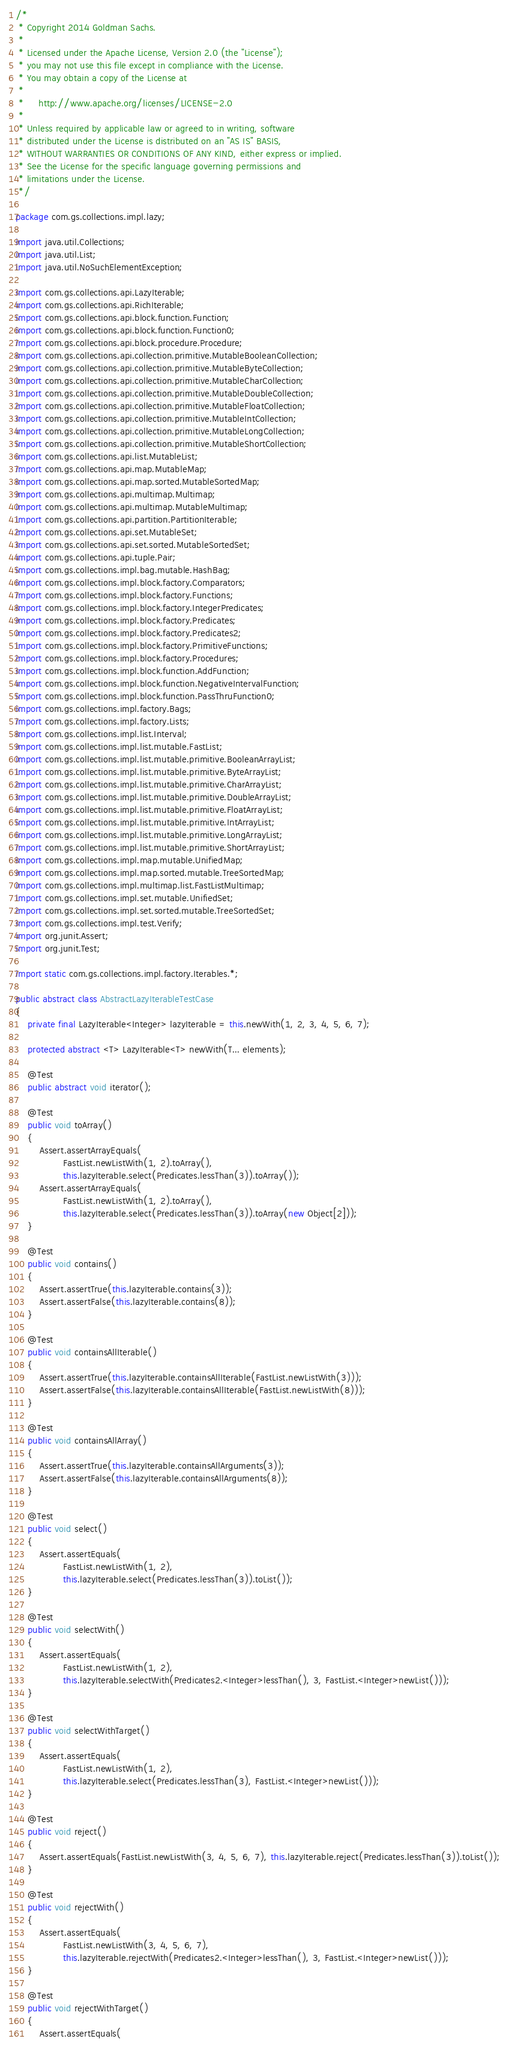<code> <loc_0><loc_0><loc_500><loc_500><_Java_>/*
 * Copyright 2014 Goldman Sachs.
 *
 * Licensed under the Apache License, Version 2.0 (the "License");
 * you may not use this file except in compliance with the License.
 * You may obtain a copy of the License at
 *
 *     http://www.apache.org/licenses/LICENSE-2.0
 *
 * Unless required by applicable law or agreed to in writing, software
 * distributed under the License is distributed on an "AS IS" BASIS,
 * WITHOUT WARRANTIES OR CONDITIONS OF ANY KIND, either express or implied.
 * See the License for the specific language governing permissions and
 * limitations under the License.
 */

package com.gs.collections.impl.lazy;

import java.util.Collections;
import java.util.List;
import java.util.NoSuchElementException;

import com.gs.collections.api.LazyIterable;
import com.gs.collections.api.RichIterable;
import com.gs.collections.api.block.function.Function;
import com.gs.collections.api.block.function.Function0;
import com.gs.collections.api.block.procedure.Procedure;
import com.gs.collections.api.collection.primitive.MutableBooleanCollection;
import com.gs.collections.api.collection.primitive.MutableByteCollection;
import com.gs.collections.api.collection.primitive.MutableCharCollection;
import com.gs.collections.api.collection.primitive.MutableDoubleCollection;
import com.gs.collections.api.collection.primitive.MutableFloatCollection;
import com.gs.collections.api.collection.primitive.MutableIntCollection;
import com.gs.collections.api.collection.primitive.MutableLongCollection;
import com.gs.collections.api.collection.primitive.MutableShortCollection;
import com.gs.collections.api.list.MutableList;
import com.gs.collections.api.map.MutableMap;
import com.gs.collections.api.map.sorted.MutableSortedMap;
import com.gs.collections.api.multimap.Multimap;
import com.gs.collections.api.multimap.MutableMultimap;
import com.gs.collections.api.partition.PartitionIterable;
import com.gs.collections.api.set.MutableSet;
import com.gs.collections.api.set.sorted.MutableSortedSet;
import com.gs.collections.api.tuple.Pair;
import com.gs.collections.impl.bag.mutable.HashBag;
import com.gs.collections.impl.block.factory.Comparators;
import com.gs.collections.impl.block.factory.Functions;
import com.gs.collections.impl.block.factory.IntegerPredicates;
import com.gs.collections.impl.block.factory.Predicates;
import com.gs.collections.impl.block.factory.Predicates2;
import com.gs.collections.impl.block.factory.PrimitiveFunctions;
import com.gs.collections.impl.block.factory.Procedures;
import com.gs.collections.impl.block.function.AddFunction;
import com.gs.collections.impl.block.function.NegativeIntervalFunction;
import com.gs.collections.impl.block.function.PassThruFunction0;
import com.gs.collections.impl.factory.Bags;
import com.gs.collections.impl.factory.Lists;
import com.gs.collections.impl.list.Interval;
import com.gs.collections.impl.list.mutable.FastList;
import com.gs.collections.impl.list.mutable.primitive.BooleanArrayList;
import com.gs.collections.impl.list.mutable.primitive.ByteArrayList;
import com.gs.collections.impl.list.mutable.primitive.CharArrayList;
import com.gs.collections.impl.list.mutable.primitive.DoubleArrayList;
import com.gs.collections.impl.list.mutable.primitive.FloatArrayList;
import com.gs.collections.impl.list.mutable.primitive.IntArrayList;
import com.gs.collections.impl.list.mutable.primitive.LongArrayList;
import com.gs.collections.impl.list.mutable.primitive.ShortArrayList;
import com.gs.collections.impl.map.mutable.UnifiedMap;
import com.gs.collections.impl.map.sorted.mutable.TreeSortedMap;
import com.gs.collections.impl.multimap.list.FastListMultimap;
import com.gs.collections.impl.set.mutable.UnifiedSet;
import com.gs.collections.impl.set.sorted.mutable.TreeSortedSet;
import com.gs.collections.impl.test.Verify;
import org.junit.Assert;
import org.junit.Test;

import static com.gs.collections.impl.factory.Iterables.*;

public abstract class AbstractLazyIterableTestCase
{
    private final LazyIterable<Integer> lazyIterable = this.newWith(1, 2, 3, 4, 5, 6, 7);

    protected abstract <T> LazyIterable<T> newWith(T... elements);

    @Test
    public abstract void iterator();

    @Test
    public void toArray()
    {
        Assert.assertArrayEquals(
                FastList.newListWith(1, 2).toArray(),
                this.lazyIterable.select(Predicates.lessThan(3)).toArray());
        Assert.assertArrayEquals(
                FastList.newListWith(1, 2).toArray(),
                this.lazyIterable.select(Predicates.lessThan(3)).toArray(new Object[2]));
    }

    @Test
    public void contains()
    {
        Assert.assertTrue(this.lazyIterable.contains(3));
        Assert.assertFalse(this.lazyIterable.contains(8));
    }

    @Test
    public void containsAllIterable()
    {
        Assert.assertTrue(this.lazyIterable.containsAllIterable(FastList.newListWith(3)));
        Assert.assertFalse(this.lazyIterable.containsAllIterable(FastList.newListWith(8)));
    }

    @Test
    public void containsAllArray()
    {
        Assert.assertTrue(this.lazyIterable.containsAllArguments(3));
        Assert.assertFalse(this.lazyIterable.containsAllArguments(8));
    }

    @Test
    public void select()
    {
        Assert.assertEquals(
                FastList.newListWith(1, 2),
                this.lazyIterable.select(Predicates.lessThan(3)).toList());
    }

    @Test
    public void selectWith()
    {
        Assert.assertEquals(
                FastList.newListWith(1, 2),
                this.lazyIterable.selectWith(Predicates2.<Integer>lessThan(), 3, FastList.<Integer>newList()));
    }

    @Test
    public void selectWithTarget()
    {
        Assert.assertEquals(
                FastList.newListWith(1, 2),
                this.lazyIterable.select(Predicates.lessThan(3), FastList.<Integer>newList()));
    }

    @Test
    public void reject()
    {
        Assert.assertEquals(FastList.newListWith(3, 4, 5, 6, 7), this.lazyIterable.reject(Predicates.lessThan(3)).toList());
    }

    @Test
    public void rejectWith()
    {
        Assert.assertEquals(
                FastList.newListWith(3, 4, 5, 6, 7),
                this.lazyIterable.rejectWith(Predicates2.<Integer>lessThan(), 3, FastList.<Integer>newList()));
    }

    @Test
    public void rejectWithTarget()
    {
        Assert.assertEquals(</code> 